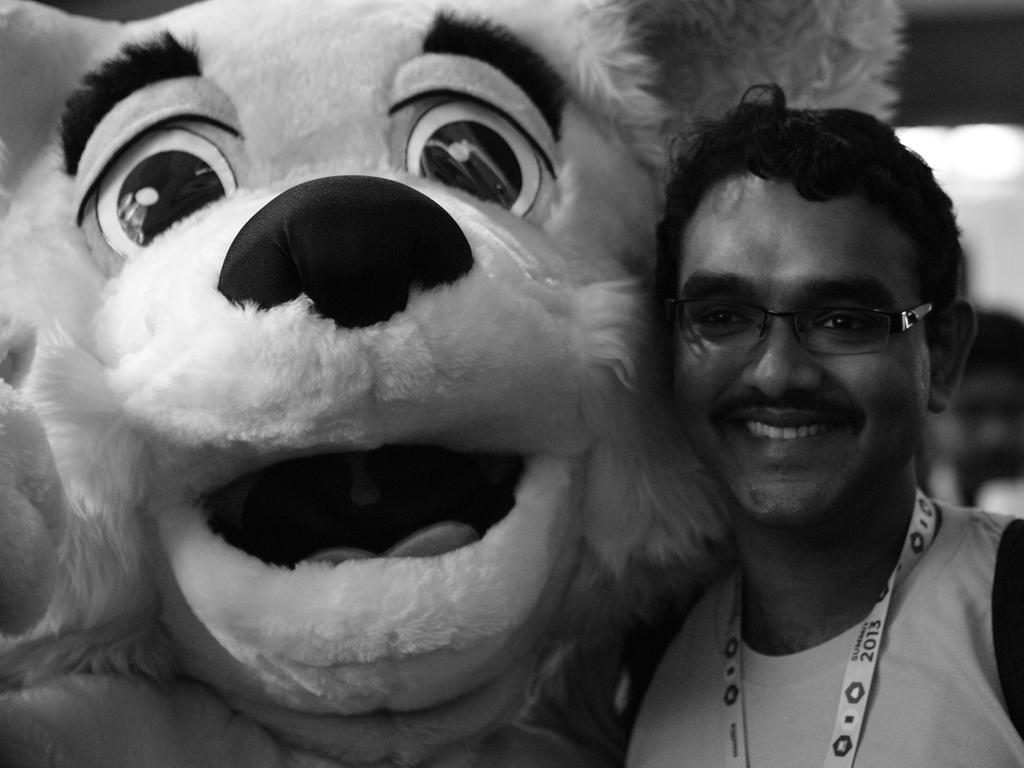Can you describe this image briefly? In this image we can see a man standing and smiling. He is wearing glasses, next to him we can see a clown. 